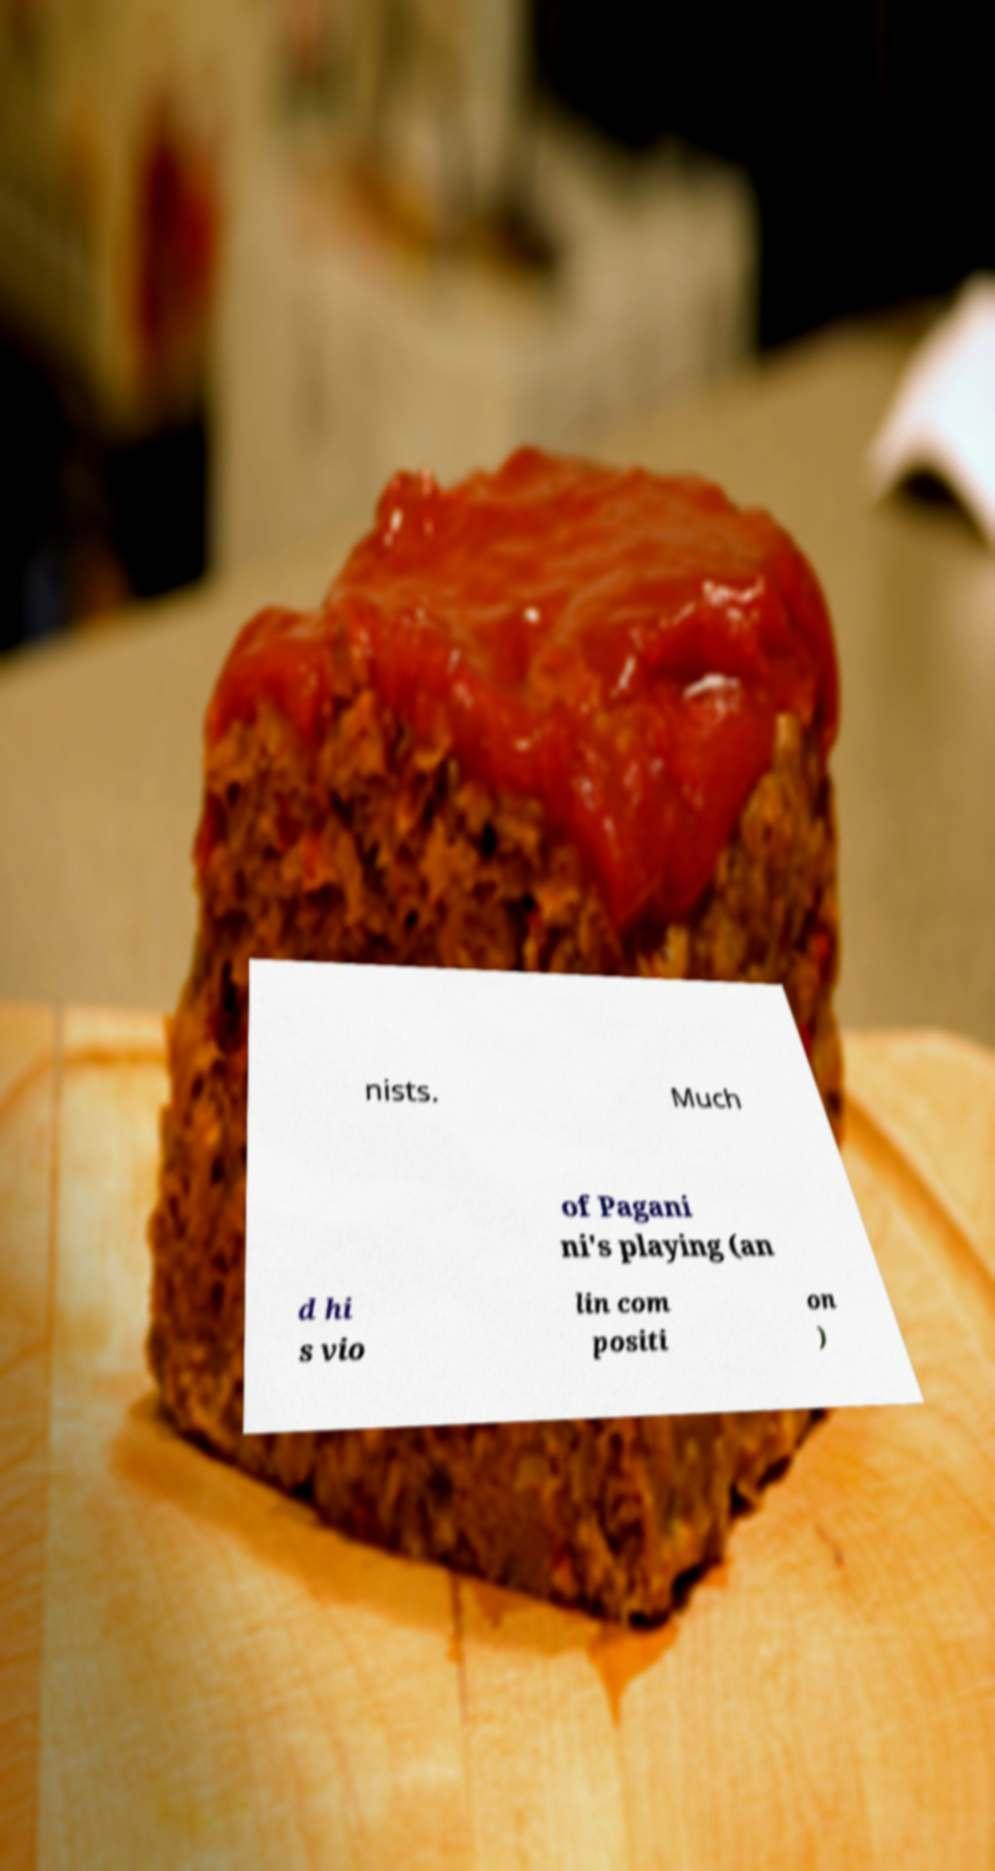What messages or text are displayed in this image? I need them in a readable, typed format. nists. Much of Pagani ni's playing (an d hi s vio lin com positi on ) 